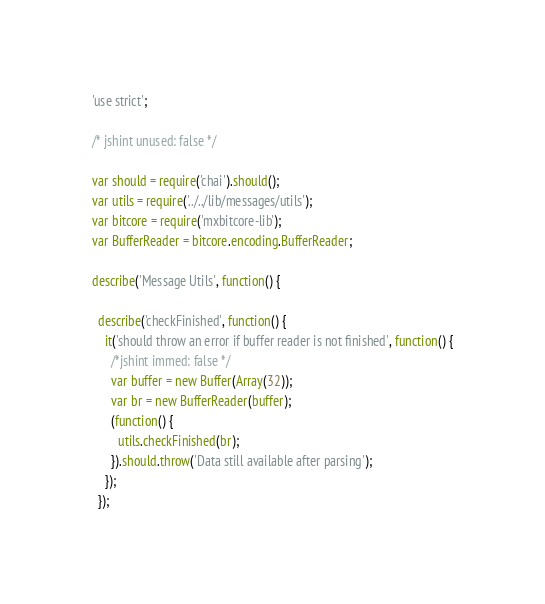Convert code to text. <code><loc_0><loc_0><loc_500><loc_500><_JavaScript_>'use strict';

/* jshint unused: false */

var should = require('chai').should();
var utils = require('../../lib/messages/utils');
var bitcore = require('mxbitcore-lib');
var BufferReader = bitcore.encoding.BufferReader;

describe('Message Utils', function() {

  describe('checkFinished', function() {
    it('should throw an error if buffer reader is not finished', function() {
      /*jshint immed: false */
      var buffer = new Buffer(Array(32));
      var br = new BufferReader(buffer);
      (function() {
        utils.checkFinished(br);
      }).should.throw('Data still available after parsing');
    });
  });
</code> 